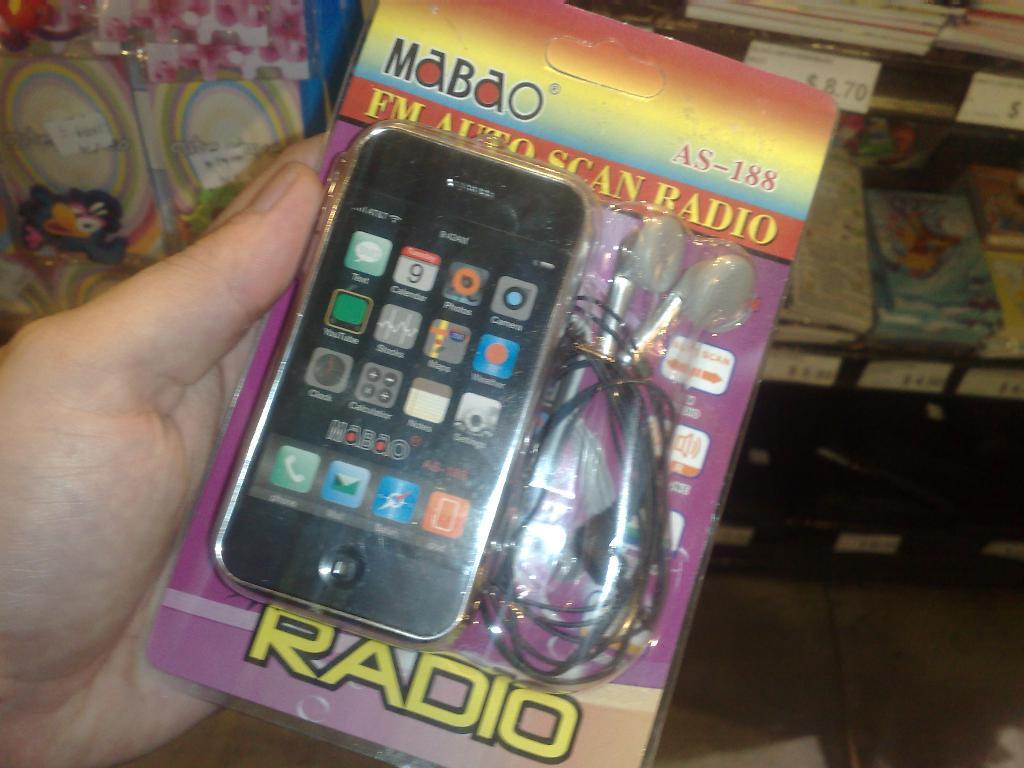Please provide a concise description of this image. In this picture we can see a person's hand holding an object. Behind the hand, there are some objects in the racks and there are price stickers. 